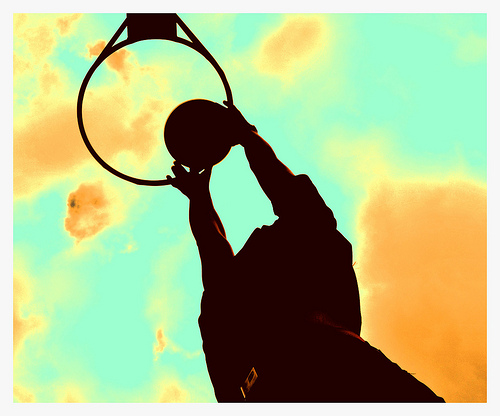<image>
Is there a hoop under the ball? Yes. The hoop is positioned underneath the ball, with the ball above it in the vertical space. Is there a basketball behind the hoop? No. The basketball is not behind the hoop. From this viewpoint, the basketball appears to be positioned elsewhere in the scene. 